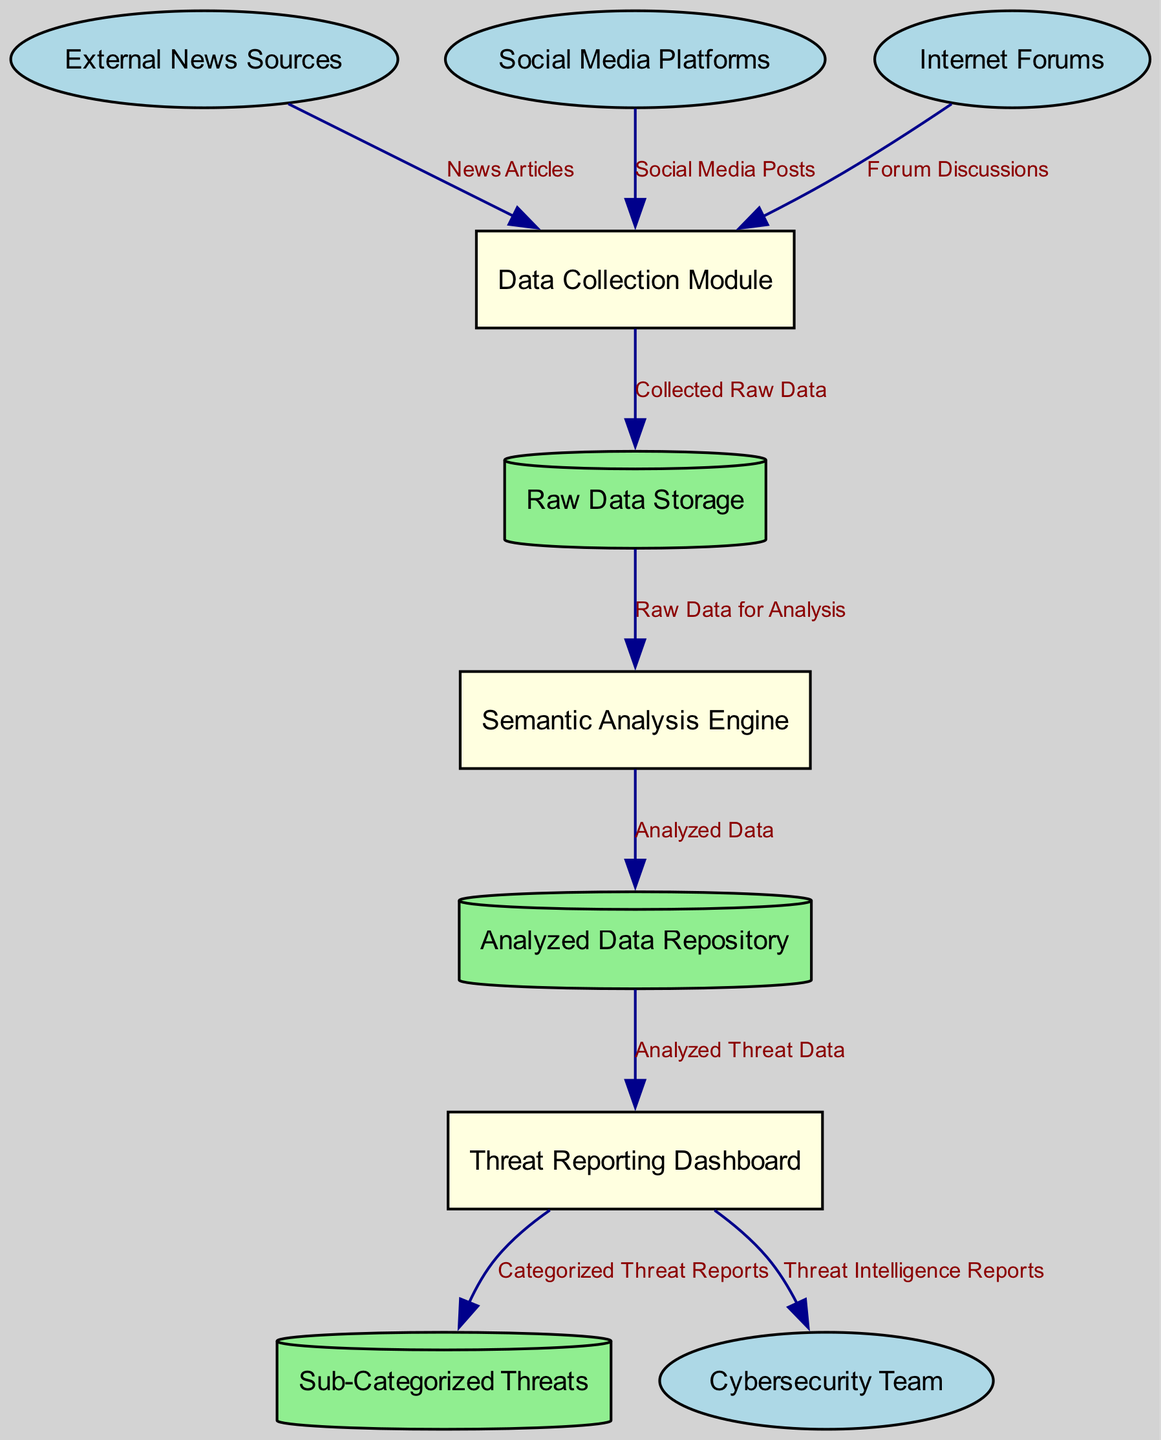What are the types of external entities in this diagram? The diagram contains three external entities: External News Sources, Social Media Platforms, and Internet Forums.
Answer: External News Sources, Social Media Platforms, Internet Forums How many processes are identified in the diagram? By reviewing the entities section of the diagram, the identified processes are Data Collection Module, Semantic Analysis Engine, and Threat Reporting Dashboard, totaling three processes.
Answer: Three What data is collected from Social Media Platforms? The diagram shows that the Data Collection Module receives "Social Media Posts" from Social Media Platforms.
Answer: Social Media Posts What is the flow of data after it is processed by the Semantic Analysis Engine? After data is processed by the Semantic Analysis Engine, it flows to the Analyzed Data Repository labeled as "Analyzed Data."
Answer: Analyzed Data Which entity receives the Threat Intelligence Reports? The Threat Reporting Dashboard sends "Threat Intelligence Reports" to the Cybersecurity Team as indicated by the data flow.
Answer: Cybersecurity Team What type of data is stored in the "Sub-Categorized Threats"? The Threat Reporting Dashboard sends "Categorized Threat Reports" to the Sub-Categorized Threats data store indicating what type of data is stored there.
Answer: Categorized Threat Reports What is the purpose of the Data Collection Module? The Data Collection Module collects raw data from various external entities, which include news articles, social media posts, and forum discussions, indicating its role as a data gathering process.
Answer: Collects raw data How many data stores are included in the diagram? The diagram identifies three data stores: Raw Data Storage, Analyzed Data Repository, and Sub-Categorized Threats, totaling three data stores in the system.
Answer: Three 